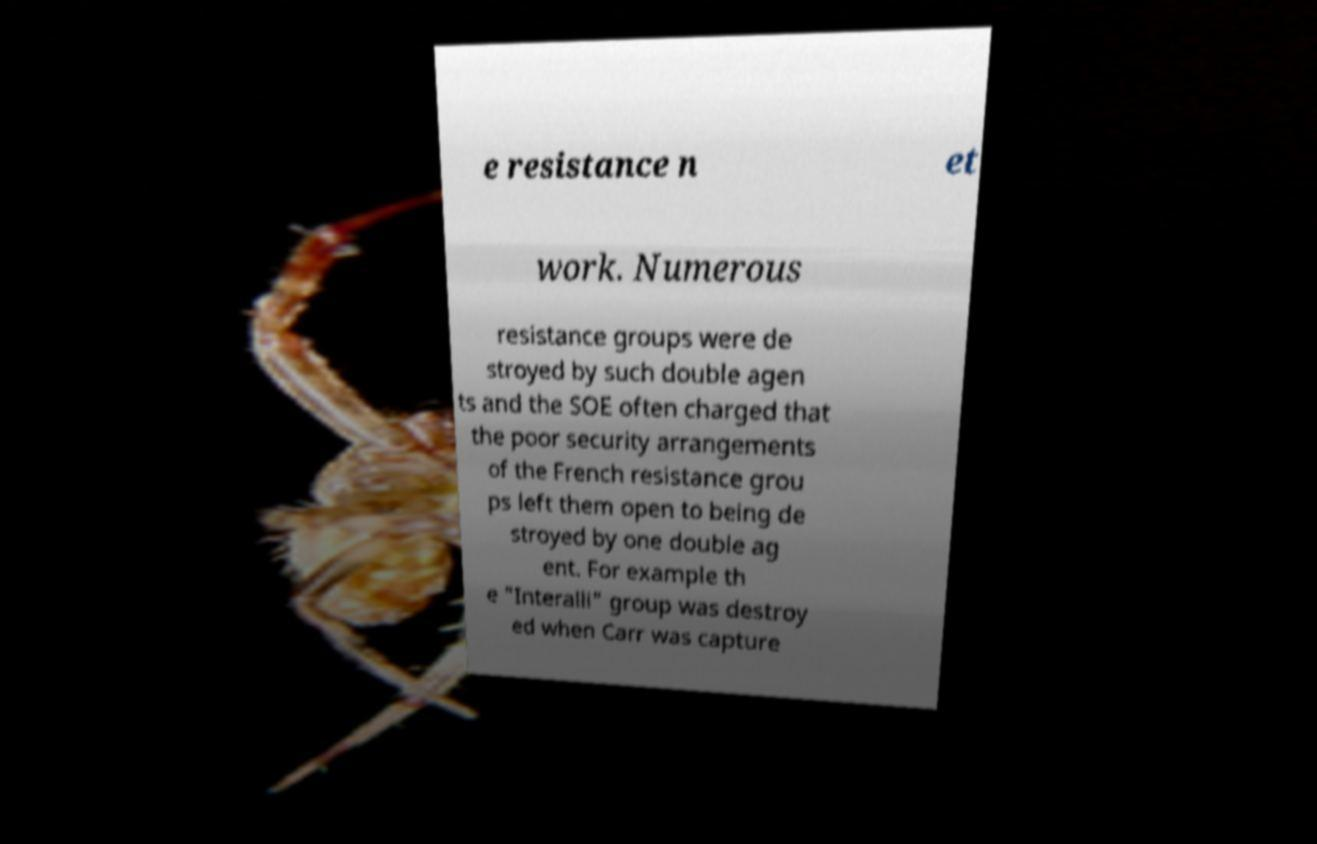There's text embedded in this image that I need extracted. Can you transcribe it verbatim? e resistance n et work. Numerous resistance groups were de stroyed by such double agen ts and the SOE often charged that the poor security arrangements of the French resistance grou ps left them open to being de stroyed by one double ag ent. For example th e "Interalli" group was destroy ed when Carr was capture 